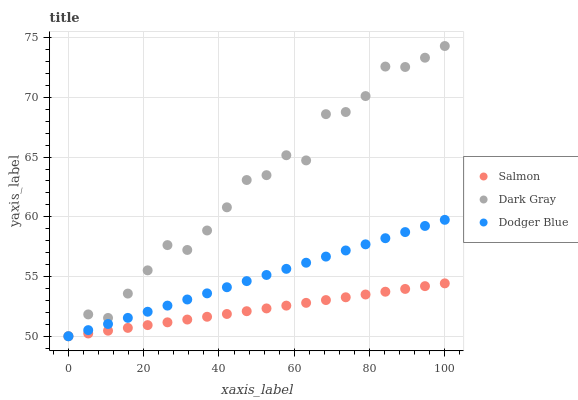Does Salmon have the minimum area under the curve?
Answer yes or no. Yes. Does Dark Gray have the maximum area under the curve?
Answer yes or no. Yes. Does Dodger Blue have the minimum area under the curve?
Answer yes or no. No. Does Dodger Blue have the maximum area under the curve?
Answer yes or no. No. Is Salmon the smoothest?
Answer yes or no. Yes. Is Dark Gray the roughest?
Answer yes or no. Yes. Is Dodger Blue the smoothest?
Answer yes or no. No. Is Dodger Blue the roughest?
Answer yes or no. No. Does Dark Gray have the lowest value?
Answer yes or no. Yes. Does Dark Gray have the highest value?
Answer yes or no. Yes. Does Dodger Blue have the highest value?
Answer yes or no. No. Does Dodger Blue intersect Dark Gray?
Answer yes or no. Yes. Is Dodger Blue less than Dark Gray?
Answer yes or no. No. Is Dodger Blue greater than Dark Gray?
Answer yes or no. No. 